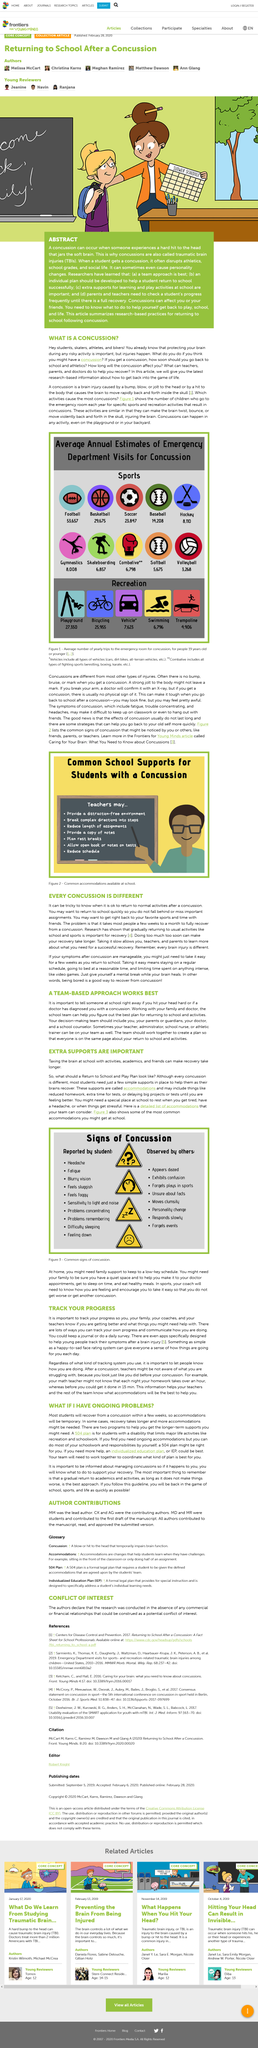Identify some key points in this picture. Football has the highest number of concussions among all sports. Two programs that can provide extended support in the long-term are the Section 504 plan and the Individualized Education Plan (IEP). A gradual return to academics and activities is the best approach for ensuring a successful and safe return to school following a concussion. Figure 3 details the common signs of concussion, which are described in the figure. A teacher's last action to support students with a concussion is to reduce their schedule in order to allow them to fully recover. 